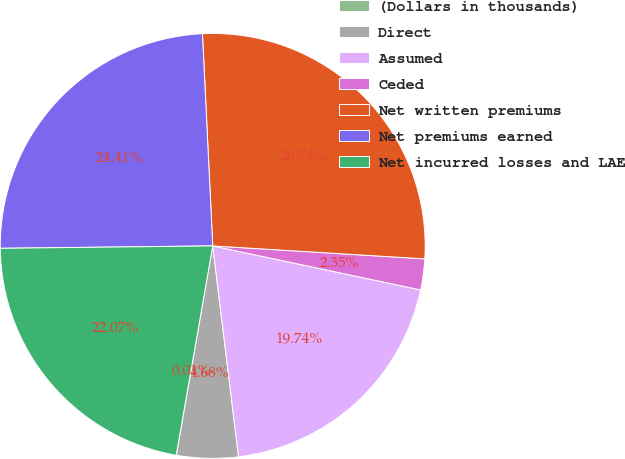Convert chart. <chart><loc_0><loc_0><loc_500><loc_500><pie_chart><fcel>(Dollars in thousands)<fcel>Direct<fcel>Assumed<fcel>Ceded<fcel>Net written premiums<fcel>Net premiums earned<fcel>Net incurred losses and LAE<nl><fcel>0.01%<fcel>4.68%<fcel>19.74%<fcel>2.35%<fcel>26.74%<fcel>24.41%<fcel>22.07%<nl></chart> 